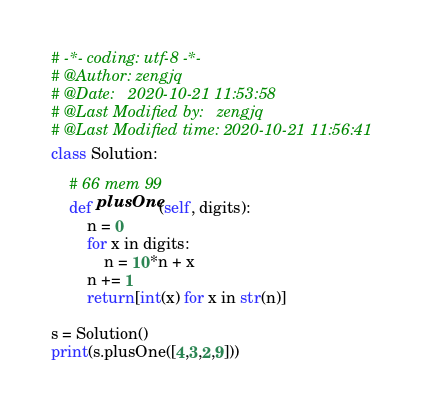Convert code to text. <code><loc_0><loc_0><loc_500><loc_500><_Python_># -*- coding: utf-8 -*-
# @Author: zengjq
# @Date:   2020-10-21 11:53:58
# @Last Modified by:   zengjq
# @Last Modified time: 2020-10-21 11:56:41
class Solution:

    # 66 mem 99
    def plusOne(self, digits):
        n = 0
        for x in digits:
            n = 10*n + x
        n += 1
        return[int(x) for x in str(n)]

s = Solution()
print(s.plusOne([4,3,2,9]))</code> 